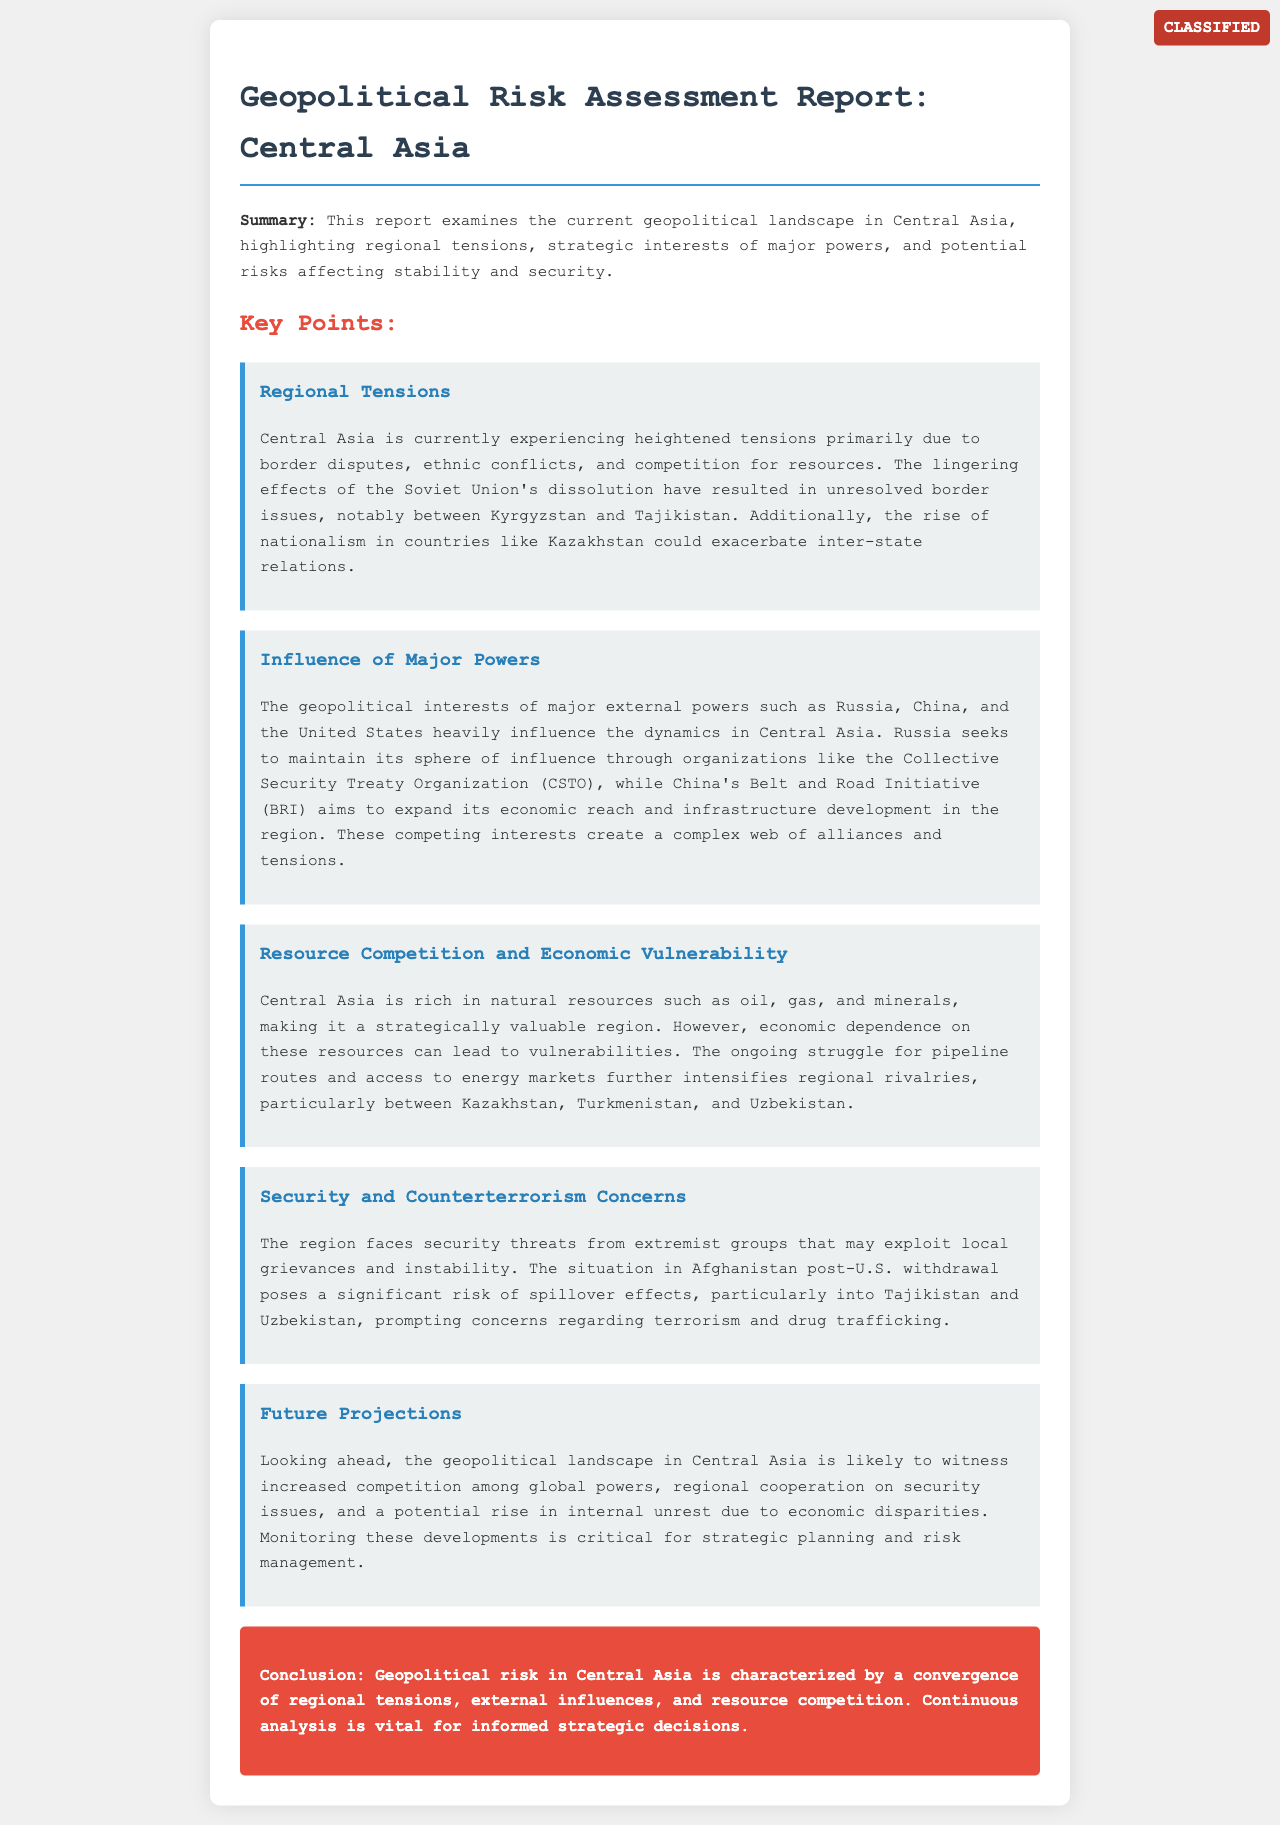What is the main topic of the report? The main topic of the report is the geopolitical landscape in Central Asia, focusing on regional tensions and strategic interests.
Answer: Geopolitical Risk Assessment: Central Asia Which countries are involved in border disputes? The document highlights border disputes primarily between Kyrgyzstan and Tajikistan.
Answer: Kyrgyzstan and Tajikistan What organization does Russia use to maintain its influence? Russia seeks to maintain its influence through the Collective Security Treaty Organization (CSTO).
Answer: CSTO What initiative is China using to expand its economic reach? China's Belt and Road Initiative (BRI) aims to expand its economic reach in Central Asia.
Answer: Belt and Road Initiative (BRI) What security threat is mentioned in relation to Afghanistan? The situation in Afghanistan post-U.S. withdrawal poses risks of terrorism and drug trafficking.
Answer: Terrorism and drug trafficking What is a potential internal issue mentioned for the future? The report mentions a potential rise in internal unrest due to economic disparities.
Answer: Internal unrest What are the natural resources that make Central Asia strategically valuable? Central Asia is rich in oil, gas, and minerals, making it strategically valuable.
Answer: Oil, gas, and minerals What kind of analysis is deemed vital for strategic decisions? Continuous analysis is vital for informed strategic decisions.
Answer: Continuous analysis 